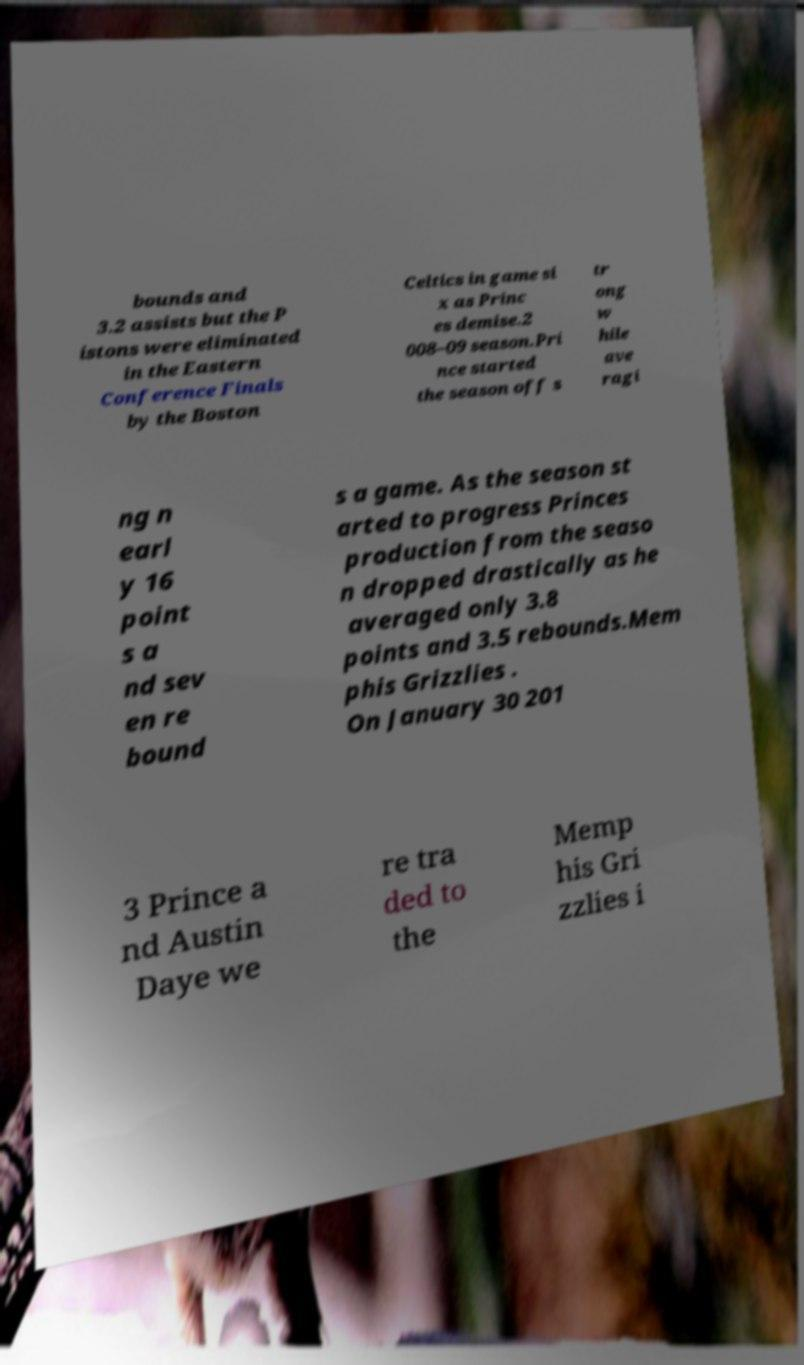Could you assist in decoding the text presented in this image and type it out clearly? bounds and 3.2 assists but the P istons were eliminated in the Eastern Conference Finals by the Boston Celtics in game si x as Princ es demise.2 008–09 season.Pri nce started the season off s tr ong w hile ave ragi ng n earl y 16 point s a nd sev en re bound s a game. As the season st arted to progress Princes production from the seaso n dropped drastically as he averaged only 3.8 points and 3.5 rebounds.Mem phis Grizzlies . On January 30 201 3 Prince a nd Austin Daye we re tra ded to the Memp his Gri zzlies i 